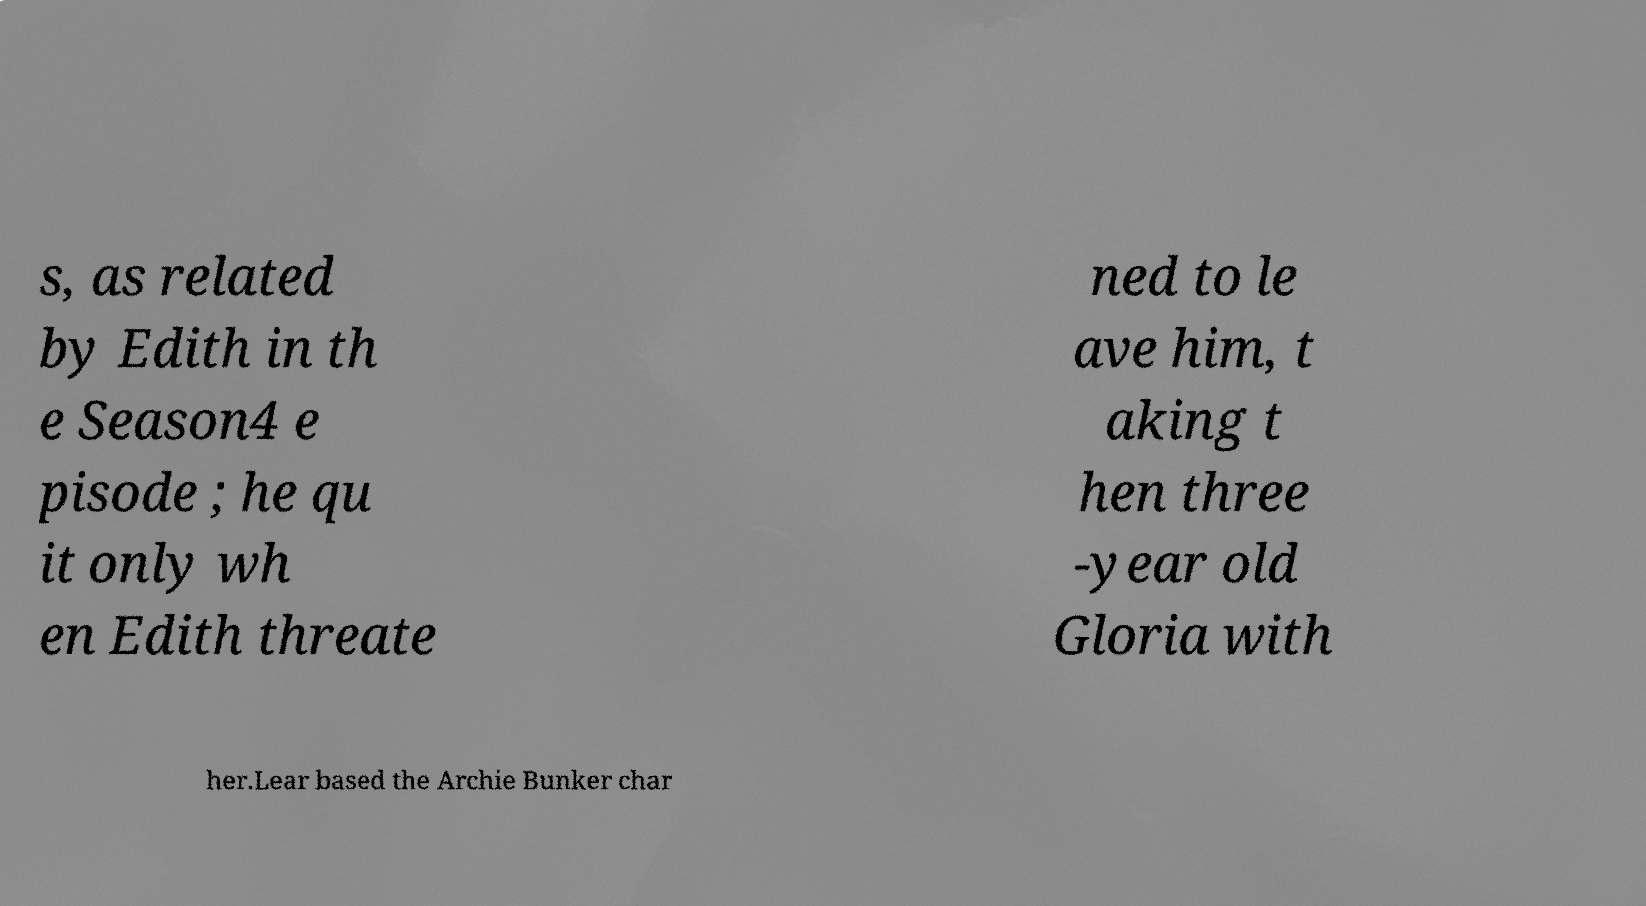Can you accurately transcribe the text from the provided image for me? s, as related by Edith in th e Season4 e pisode ; he qu it only wh en Edith threate ned to le ave him, t aking t hen three -year old Gloria with her.Lear based the Archie Bunker char 